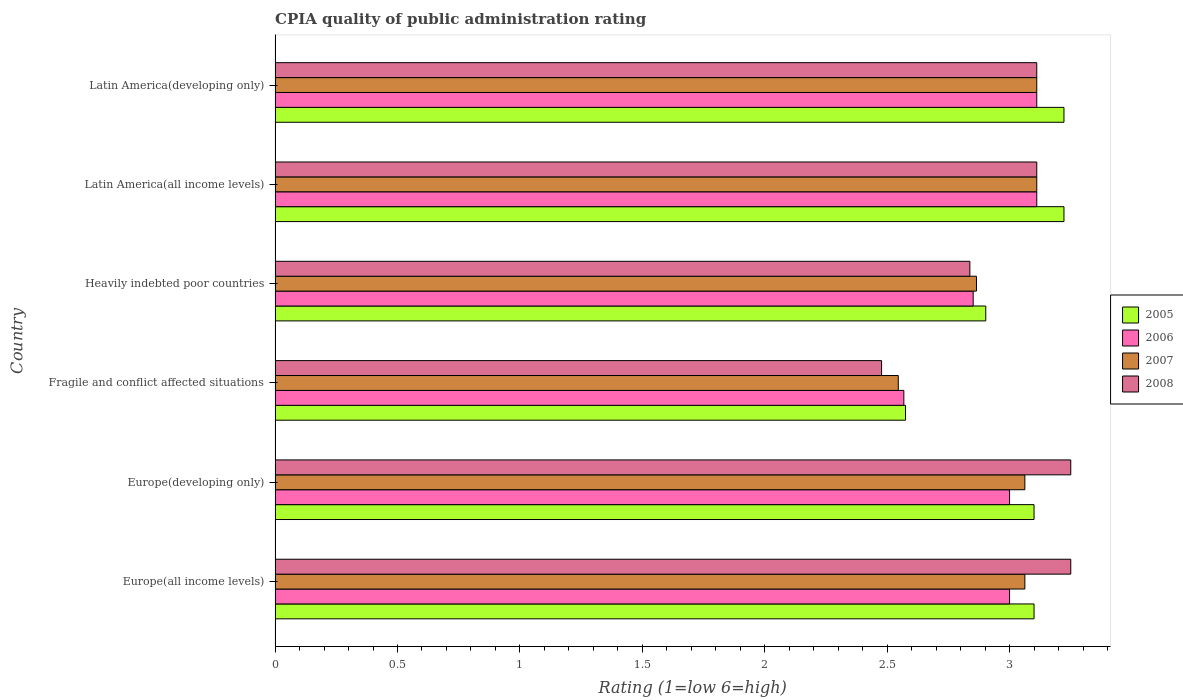How many bars are there on the 4th tick from the top?
Keep it short and to the point. 4. How many bars are there on the 6th tick from the bottom?
Offer a terse response. 4. What is the label of the 3rd group of bars from the top?
Make the answer very short. Heavily indebted poor countries. In how many cases, is the number of bars for a given country not equal to the number of legend labels?
Keep it short and to the point. 0. Across all countries, what is the maximum CPIA rating in 2007?
Keep it short and to the point. 3.11. Across all countries, what is the minimum CPIA rating in 2005?
Ensure brevity in your answer.  2.58. In which country was the CPIA rating in 2007 maximum?
Ensure brevity in your answer.  Latin America(all income levels). In which country was the CPIA rating in 2005 minimum?
Make the answer very short. Fragile and conflict affected situations. What is the total CPIA rating in 2008 in the graph?
Offer a very short reply. 18.04. What is the difference between the CPIA rating in 2006 in Europe(developing only) and that in Latin America(developing only)?
Give a very brief answer. -0.11. What is the difference between the CPIA rating in 2006 in Latin America(all income levels) and the CPIA rating in 2005 in Europe(all income levels)?
Offer a terse response. 0.01. What is the average CPIA rating in 2005 per country?
Your answer should be very brief. 3.02. What is the difference between the CPIA rating in 2005 and CPIA rating in 2007 in Latin America(all income levels)?
Make the answer very short. 0.11. What is the ratio of the CPIA rating in 2007 in Heavily indebted poor countries to that in Latin America(all income levels)?
Offer a terse response. 0.92. Is the CPIA rating in 2008 in Europe(all income levels) less than that in Latin America(all income levels)?
Provide a short and direct response. No. Is the difference between the CPIA rating in 2005 in Europe(developing only) and Latin America(developing only) greater than the difference between the CPIA rating in 2007 in Europe(developing only) and Latin America(developing only)?
Your answer should be compact. No. What is the difference between the highest and the second highest CPIA rating in 2005?
Keep it short and to the point. 0. What is the difference between the highest and the lowest CPIA rating in 2008?
Provide a short and direct response. 0.77. In how many countries, is the CPIA rating in 2005 greater than the average CPIA rating in 2005 taken over all countries?
Ensure brevity in your answer.  4. Is the sum of the CPIA rating in 2008 in Fragile and conflict affected situations and Latin America(all income levels) greater than the maximum CPIA rating in 2005 across all countries?
Keep it short and to the point. Yes. What does the 3rd bar from the top in Latin America(all income levels) represents?
Keep it short and to the point. 2006. What does the 3rd bar from the bottom in Europe(all income levels) represents?
Provide a succinct answer. 2007. Is it the case that in every country, the sum of the CPIA rating in 2007 and CPIA rating in 2008 is greater than the CPIA rating in 2005?
Provide a short and direct response. Yes. Are all the bars in the graph horizontal?
Your response must be concise. Yes. How many countries are there in the graph?
Ensure brevity in your answer.  6. Are the values on the major ticks of X-axis written in scientific E-notation?
Provide a succinct answer. No. Does the graph contain any zero values?
Provide a succinct answer. No. Does the graph contain grids?
Make the answer very short. No. Where does the legend appear in the graph?
Provide a succinct answer. Center right. How are the legend labels stacked?
Give a very brief answer. Vertical. What is the title of the graph?
Provide a succinct answer. CPIA quality of public administration rating. Does "1977" appear as one of the legend labels in the graph?
Ensure brevity in your answer.  No. What is the Rating (1=low 6=high) of 2005 in Europe(all income levels)?
Keep it short and to the point. 3.1. What is the Rating (1=low 6=high) in 2007 in Europe(all income levels)?
Keep it short and to the point. 3.06. What is the Rating (1=low 6=high) of 2008 in Europe(all income levels)?
Your answer should be very brief. 3.25. What is the Rating (1=low 6=high) of 2005 in Europe(developing only)?
Offer a very short reply. 3.1. What is the Rating (1=low 6=high) of 2007 in Europe(developing only)?
Provide a succinct answer. 3.06. What is the Rating (1=low 6=high) in 2008 in Europe(developing only)?
Offer a terse response. 3.25. What is the Rating (1=low 6=high) in 2005 in Fragile and conflict affected situations?
Provide a succinct answer. 2.58. What is the Rating (1=low 6=high) in 2006 in Fragile and conflict affected situations?
Give a very brief answer. 2.57. What is the Rating (1=low 6=high) of 2007 in Fragile and conflict affected situations?
Keep it short and to the point. 2.55. What is the Rating (1=low 6=high) in 2008 in Fragile and conflict affected situations?
Keep it short and to the point. 2.48. What is the Rating (1=low 6=high) of 2005 in Heavily indebted poor countries?
Keep it short and to the point. 2.9. What is the Rating (1=low 6=high) of 2006 in Heavily indebted poor countries?
Ensure brevity in your answer.  2.85. What is the Rating (1=low 6=high) in 2007 in Heavily indebted poor countries?
Offer a terse response. 2.86. What is the Rating (1=low 6=high) of 2008 in Heavily indebted poor countries?
Provide a short and direct response. 2.84. What is the Rating (1=low 6=high) in 2005 in Latin America(all income levels)?
Give a very brief answer. 3.22. What is the Rating (1=low 6=high) in 2006 in Latin America(all income levels)?
Give a very brief answer. 3.11. What is the Rating (1=low 6=high) of 2007 in Latin America(all income levels)?
Offer a very short reply. 3.11. What is the Rating (1=low 6=high) of 2008 in Latin America(all income levels)?
Your answer should be very brief. 3.11. What is the Rating (1=low 6=high) of 2005 in Latin America(developing only)?
Give a very brief answer. 3.22. What is the Rating (1=low 6=high) of 2006 in Latin America(developing only)?
Ensure brevity in your answer.  3.11. What is the Rating (1=low 6=high) in 2007 in Latin America(developing only)?
Make the answer very short. 3.11. What is the Rating (1=low 6=high) in 2008 in Latin America(developing only)?
Your answer should be compact. 3.11. Across all countries, what is the maximum Rating (1=low 6=high) of 2005?
Make the answer very short. 3.22. Across all countries, what is the maximum Rating (1=low 6=high) in 2006?
Offer a very short reply. 3.11. Across all countries, what is the maximum Rating (1=low 6=high) of 2007?
Your answer should be very brief. 3.11. Across all countries, what is the maximum Rating (1=low 6=high) in 2008?
Give a very brief answer. 3.25. Across all countries, what is the minimum Rating (1=low 6=high) in 2005?
Your response must be concise. 2.58. Across all countries, what is the minimum Rating (1=low 6=high) of 2006?
Provide a short and direct response. 2.57. Across all countries, what is the minimum Rating (1=low 6=high) of 2007?
Offer a very short reply. 2.55. Across all countries, what is the minimum Rating (1=low 6=high) of 2008?
Provide a succinct answer. 2.48. What is the total Rating (1=low 6=high) in 2005 in the graph?
Offer a very short reply. 18.12. What is the total Rating (1=low 6=high) of 2006 in the graph?
Your answer should be very brief. 17.64. What is the total Rating (1=low 6=high) in 2007 in the graph?
Ensure brevity in your answer.  17.76. What is the total Rating (1=low 6=high) of 2008 in the graph?
Keep it short and to the point. 18.04. What is the difference between the Rating (1=low 6=high) in 2008 in Europe(all income levels) and that in Europe(developing only)?
Offer a terse response. 0. What is the difference between the Rating (1=low 6=high) of 2005 in Europe(all income levels) and that in Fragile and conflict affected situations?
Offer a terse response. 0.53. What is the difference between the Rating (1=low 6=high) of 2006 in Europe(all income levels) and that in Fragile and conflict affected situations?
Keep it short and to the point. 0.43. What is the difference between the Rating (1=low 6=high) in 2007 in Europe(all income levels) and that in Fragile and conflict affected situations?
Your response must be concise. 0.52. What is the difference between the Rating (1=low 6=high) of 2008 in Europe(all income levels) and that in Fragile and conflict affected situations?
Offer a very short reply. 0.77. What is the difference between the Rating (1=low 6=high) of 2005 in Europe(all income levels) and that in Heavily indebted poor countries?
Your answer should be compact. 0.2. What is the difference between the Rating (1=low 6=high) of 2006 in Europe(all income levels) and that in Heavily indebted poor countries?
Offer a terse response. 0.15. What is the difference between the Rating (1=low 6=high) of 2007 in Europe(all income levels) and that in Heavily indebted poor countries?
Your answer should be very brief. 0.2. What is the difference between the Rating (1=low 6=high) of 2008 in Europe(all income levels) and that in Heavily indebted poor countries?
Provide a short and direct response. 0.41. What is the difference between the Rating (1=low 6=high) of 2005 in Europe(all income levels) and that in Latin America(all income levels)?
Make the answer very short. -0.12. What is the difference between the Rating (1=low 6=high) of 2006 in Europe(all income levels) and that in Latin America(all income levels)?
Keep it short and to the point. -0.11. What is the difference between the Rating (1=low 6=high) of 2007 in Europe(all income levels) and that in Latin America(all income levels)?
Make the answer very short. -0.05. What is the difference between the Rating (1=low 6=high) in 2008 in Europe(all income levels) and that in Latin America(all income levels)?
Make the answer very short. 0.14. What is the difference between the Rating (1=low 6=high) in 2005 in Europe(all income levels) and that in Latin America(developing only)?
Offer a very short reply. -0.12. What is the difference between the Rating (1=low 6=high) in 2006 in Europe(all income levels) and that in Latin America(developing only)?
Keep it short and to the point. -0.11. What is the difference between the Rating (1=low 6=high) in 2007 in Europe(all income levels) and that in Latin America(developing only)?
Provide a short and direct response. -0.05. What is the difference between the Rating (1=low 6=high) in 2008 in Europe(all income levels) and that in Latin America(developing only)?
Offer a terse response. 0.14. What is the difference between the Rating (1=low 6=high) of 2005 in Europe(developing only) and that in Fragile and conflict affected situations?
Provide a short and direct response. 0.53. What is the difference between the Rating (1=low 6=high) in 2006 in Europe(developing only) and that in Fragile and conflict affected situations?
Keep it short and to the point. 0.43. What is the difference between the Rating (1=low 6=high) of 2007 in Europe(developing only) and that in Fragile and conflict affected situations?
Your response must be concise. 0.52. What is the difference between the Rating (1=low 6=high) in 2008 in Europe(developing only) and that in Fragile and conflict affected situations?
Offer a terse response. 0.77. What is the difference between the Rating (1=low 6=high) in 2005 in Europe(developing only) and that in Heavily indebted poor countries?
Ensure brevity in your answer.  0.2. What is the difference between the Rating (1=low 6=high) of 2006 in Europe(developing only) and that in Heavily indebted poor countries?
Make the answer very short. 0.15. What is the difference between the Rating (1=low 6=high) in 2007 in Europe(developing only) and that in Heavily indebted poor countries?
Keep it short and to the point. 0.2. What is the difference between the Rating (1=low 6=high) in 2008 in Europe(developing only) and that in Heavily indebted poor countries?
Offer a terse response. 0.41. What is the difference between the Rating (1=low 6=high) in 2005 in Europe(developing only) and that in Latin America(all income levels)?
Keep it short and to the point. -0.12. What is the difference between the Rating (1=low 6=high) in 2006 in Europe(developing only) and that in Latin America(all income levels)?
Keep it short and to the point. -0.11. What is the difference between the Rating (1=low 6=high) of 2007 in Europe(developing only) and that in Latin America(all income levels)?
Your answer should be compact. -0.05. What is the difference between the Rating (1=low 6=high) in 2008 in Europe(developing only) and that in Latin America(all income levels)?
Your answer should be very brief. 0.14. What is the difference between the Rating (1=low 6=high) in 2005 in Europe(developing only) and that in Latin America(developing only)?
Offer a very short reply. -0.12. What is the difference between the Rating (1=low 6=high) of 2006 in Europe(developing only) and that in Latin America(developing only)?
Your response must be concise. -0.11. What is the difference between the Rating (1=low 6=high) in 2007 in Europe(developing only) and that in Latin America(developing only)?
Your answer should be compact. -0.05. What is the difference between the Rating (1=low 6=high) of 2008 in Europe(developing only) and that in Latin America(developing only)?
Provide a succinct answer. 0.14. What is the difference between the Rating (1=low 6=high) of 2005 in Fragile and conflict affected situations and that in Heavily indebted poor countries?
Provide a succinct answer. -0.33. What is the difference between the Rating (1=low 6=high) of 2006 in Fragile and conflict affected situations and that in Heavily indebted poor countries?
Your answer should be very brief. -0.28. What is the difference between the Rating (1=low 6=high) of 2007 in Fragile and conflict affected situations and that in Heavily indebted poor countries?
Offer a very short reply. -0.32. What is the difference between the Rating (1=low 6=high) of 2008 in Fragile and conflict affected situations and that in Heavily indebted poor countries?
Offer a very short reply. -0.36. What is the difference between the Rating (1=low 6=high) in 2005 in Fragile and conflict affected situations and that in Latin America(all income levels)?
Keep it short and to the point. -0.65. What is the difference between the Rating (1=low 6=high) in 2006 in Fragile and conflict affected situations and that in Latin America(all income levels)?
Your response must be concise. -0.54. What is the difference between the Rating (1=low 6=high) in 2007 in Fragile and conflict affected situations and that in Latin America(all income levels)?
Provide a succinct answer. -0.57. What is the difference between the Rating (1=low 6=high) of 2008 in Fragile and conflict affected situations and that in Latin America(all income levels)?
Your response must be concise. -0.63. What is the difference between the Rating (1=low 6=high) in 2005 in Fragile and conflict affected situations and that in Latin America(developing only)?
Make the answer very short. -0.65. What is the difference between the Rating (1=low 6=high) in 2006 in Fragile and conflict affected situations and that in Latin America(developing only)?
Your response must be concise. -0.54. What is the difference between the Rating (1=low 6=high) of 2007 in Fragile and conflict affected situations and that in Latin America(developing only)?
Your answer should be compact. -0.57. What is the difference between the Rating (1=low 6=high) of 2008 in Fragile and conflict affected situations and that in Latin America(developing only)?
Keep it short and to the point. -0.63. What is the difference between the Rating (1=low 6=high) in 2005 in Heavily indebted poor countries and that in Latin America(all income levels)?
Make the answer very short. -0.32. What is the difference between the Rating (1=low 6=high) of 2006 in Heavily indebted poor countries and that in Latin America(all income levels)?
Your answer should be very brief. -0.26. What is the difference between the Rating (1=low 6=high) in 2007 in Heavily indebted poor countries and that in Latin America(all income levels)?
Provide a short and direct response. -0.25. What is the difference between the Rating (1=low 6=high) in 2008 in Heavily indebted poor countries and that in Latin America(all income levels)?
Provide a succinct answer. -0.27. What is the difference between the Rating (1=low 6=high) of 2005 in Heavily indebted poor countries and that in Latin America(developing only)?
Your answer should be very brief. -0.32. What is the difference between the Rating (1=low 6=high) in 2006 in Heavily indebted poor countries and that in Latin America(developing only)?
Make the answer very short. -0.26. What is the difference between the Rating (1=low 6=high) of 2007 in Heavily indebted poor countries and that in Latin America(developing only)?
Keep it short and to the point. -0.25. What is the difference between the Rating (1=low 6=high) in 2008 in Heavily indebted poor countries and that in Latin America(developing only)?
Make the answer very short. -0.27. What is the difference between the Rating (1=low 6=high) of 2005 in Latin America(all income levels) and that in Latin America(developing only)?
Your answer should be compact. 0. What is the difference between the Rating (1=low 6=high) of 2007 in Latin America(all income levels) and that in Latin America(developing only)?
Provide a succinct answer. 0. What is the difference between the Rating (1=low 6=high) of 2008 in Latin America(all income levels) and that in Latin America(developing only)?
Ensure brevity in your answer.  0. What is the difference between the Rating (1=low 6=high) of 2005 in Europe(all income levels) and the Rating (1=low 6=high) of 2006 in Europe(developing only)?
Provide a succinct answer. 0.1. What is the difference between the Rating (1=low 6=high) in 2005 in Europe(all income levels) and the Rating (1=low 6=high) in 2007 in Europe(developing only)?
Offer a terse response. 0.04. What is the difference between the Rating (1=low 6=high) of 2006 in Europe(all income levels) and the Rating (1=low 6=high) of 2007 in Europe(developing only)?
Offer a terse response. -0.06. What is the difference between the Rating (1=low 6=high) of 2007 in Europe(all income levels) and the Rating (1=low 6=high) of 2008 in Europe(developing only)?
Ensure brevity in your answer.  -0.19. What is the difference between the Rating (1=low 6=high) of 2005 in Europe(all income levels) and the Rating (1=low 6=high) of 2006 in Fragile and conflict affected situations?
Give a very brief answer. 0.53. What is the difference between the Rating (1=low 6=high) of 2005 in Europe(all income levels) and the Rating (1=low 6=high) of 2007 in Fragile and conflict affected situations?
Your response must be concise. 0.55. What is the difference between the Rating (1=low 6=high) of 2005 in Europe(all income levels) and the Rating (1=low 6=high) of 2008 in Fragile and conflict affected situations?
Make the answer very short. 0.62. What is the difference between the Rating (1=low 6=high) of 2006 in Europe(all income levels) and the Rating (1=low 6=high) of 2007 in Fragile and conflict affected situations?
Your answer should be compact. 0.45. What is the difference between the Rating (1=low 6=high) of 2006 in Europe(all income levels) and the Rating (1=low 6=high) of 2008 in Fragile and conflict affected situations?
Your answer should be compact. 0.52. What is the difference between the Rating (1=low 6=high) in 2007 in Europe(all income levels) and the Rating (1=low 6=high) in 2008 in Fragile and conflict affected situations?
Offer a terse response. 0.59. What is the difference between the Rating (1=low 6=high) in 2005 in Europe(all income levels) and the Rating (1=low 6=high) in 2006 in Heavily indebted poor countries?
Give a very brief answer. 0.25. What is the difference between the Rating (1=low 6=high) in 2005 in Europe(all income levels) and the Rating (1=low 6=high) in 2007 in Heavily indebted poor countries?
Keep it short and to the point. 0.24. What is the difference between the Rating (1=low 6=high) of 2005 in Europe(all income levels) and the Rating (1=low 6=high) of 2008 in Heavily indebted poor countries?
Your answer should be very brief. 0.26. What is the difference between the Rating (1=low 6=high) of 2006 in Europe(all income levels) and the Rating (1=low 6=high) of 2007 in Heavily indebted poor countries?
Give a very brief answer. 0.14. What is the difference between the Rating (1=low 6=high) in 2006 in Europe(all income levels) and the Rating (1=low 6=high) in 2008 in Heavily indebted poor countries?
Give a very brief answer. 0.16. What is the difference between the Rating (1=low 6=high) in 2007 in Europe(all income levels) and the Rating (1=low 6=high) in 2008 in Heavily indebted poor countries?
Offer a terse response. 0.22. What is the difference between the Rating (1=low 6=high) of 2005 in Europe(all income levels) and the Rating (1=low 6=high) of 2006 in Latin America(all income levels)?
Provide a short and direct response. -0.01. What is the difference between the Rating (1=low 6=high) in 2005 in Europe(all income levels) and the Rating (1=low 6=high) in 2007 in Latin America(all income levels)?
Offer a very short reply. -0.01. What is the difference between the Rating (1=low 6=high) in 2005 in Europe(all income levels) and the Rating (1=low 6=high) in 2008 in Latin America(all income levels)?
Give a very brief answer. -0.01. What is the difference between the Rating (1=low 6=high) of 2006 in Europe(all income levels) and the Rating (1=low 6=high) of 2007 in Latin America(all income levels)?
Offer a very short reply. -0.11. What is the difference between the Rating (1=low 6=high) of 2006 in Europe(all income levels) and the Rating (1=low 6=high) of 2008 in Latin America(all income levels)?
Your answer should be compact. -0.11. What is the difference between the Rating (1=low 6=high) in 2007 in Europe(all income levels) and the Rating (1=low 6=high) in 2008 in Latin America(all income levels)?
Provide a short and direct response. -0.05. What is the difference between the Rating (1=low 6=high) of 2005 in Europe(all income levels) and the Rating (1=low 6=high) of 2006 in Latin America(developing only)?
Keep it short and to the point. -0.01. What is the difference between the Rating (1=low 6=high) in 2005 in Europe(all income levels) and the Rating (1=low 6=high) in 2007 in Latin America(developing only)?
Your response must be concise. -0.01. What is the difference between the Rating (1=low 6=high) of 2005 in Europe(all income levels) and the Rating (1=low 6=high) of 2008 in Latin America(developing only)?
Provide a short and direct response. -0.01. What is the difference between the Rating (1=low 6=high) in 2006 in Europe(all income levels) and the Rating (1=low 6=high) in 2007 in Latin America(developing only)?
Keep it short and to the point. -0.11. What is the difference between the Rating (1=low 6=high) of 2006 in Europe(all income levels) and the Rating (1=low 6=high) of 2008 in Latin America(developing only)?
Your answer should be compact. -0.11. What is the difference between the Rating (1=low 6=high) in 2007 in Europe(all income levels) and the Rating (1=low 6=high) in 2008 in Latin America(developing only)?
Your response must be concise. -0.05. What is the difference between the Rating (1=low 6=high) of 2005 in Europe(developing only) and the Rating (1=low 6=high) of 2006 in Fragile and conflict affected situations?
Make the answer very short. 0.53. What is the difference between the Rating (1=low 6=high) of 2005 in Europe(developing only) and the Rating (1=low 6=high) of 2007 in Fragile and conflict affected situations?
Keep it short and to the point. 0.55. What is the difference between the Rating (1=low 6=high) in 2005 in Europe(developing only) and the Rating (1=low 6=high) in 2008 in Fragile and conflict affected situations?
Ensure brevity in your answer.  0.62. What is the difference between the Rating (1=low 6=high) in 2006 in Europe(developing only) and the Rating (1=low 6=high) in 2007 in Fragile and conflict affected situations?
Make the answer very short. 0.45. What is the difference between the Rating (1=low 6=high) of 2006 in Europe(developing only) and the Rating (1=low 6=high) of 2008 in Fragile and conflict affected situations?
Give a very brief answer. 0.52. What is the difference between the Rating (1=low 6=high) in 2007 in Europe(developing only) and the Rating (1=low 6=high) in 2008 in Fragile and conflict affected situations?
Your answer should be compact. 0.59. What is the difference between the Rating (1=low 6=high) of 2005 in Europe(developing only) and the Rating (1=low 6=high) of 2006 in Heavily indebted poor countries?
Offer a terse response. 0.25. What is the difference between the Rating (1=low 6=high) in 2005 in Europe(developing only) and the Rating (1=low 6=high) in 2007 in Heavily indebted poor countries?
Offer a terse response. 0.24. What is the difference between the Rating (1=low 6=high) of 2005 in Europe(developing only) and the Rating (1=low 6=high) of 2008 in Heavily indebted poor countries?
Provide a succinct answer. 0.26. What is the difference between the Rating (1=low 6=high) of 2006 in Europe(developing only) and the Rating (1=low 6=high) of 2007 in Heavily indebted poor countries?
Ensure brevity in your answer.  0.14. What is the difference between the Rating (1=low 6=high) of 2006 in Europe(developing only) and the Rating (1=low 6=high) of 2008 in Heavily indebted poor countries?
Your response must be concise. 0.16. What is the difference between the Rating (1=low 6=high) of 2007 in Europe(developing only) and the Rating (1=low 6=high) of 2008 in Heavily indebted poor countries?
Keep it short and to the point. 0.22. What is the difference between the Rating (1=low 6=high) in 2005 in Europe(developing only) and the Rating (1=low 6=high) in 2006 in Latin America(all income levels)?
Offer a very short reply. -0.01. What is the difference between the Rating (1=low 6=high) in 2005 in Europe(developing only) and the Rating (1=low 6=high) in 2007 in Latin America(all income levels)?
Offer a terse response. -0.01. What is the difference between the Rating (1=low 6=high) in 2005 in Europe(developing only) and the Rating (1=low 6=high) in 2008 in Latin America(all income levels)?
Make the answer very short. -0.01. What is the difference between the Rating (1=low 6=high) of 2006 in Europe(developing only) and the Rating (1=low 6=high) of 2007 in Latin America(all income levels)?
Make the answer very short. -0.11. What is the difference between the Rating (1=low 6=high) in 2006 in Europe(developing only) and the Rating (1=low 6=high) in 2008 in Latin America(all income levels)?
Your answer should be very brief. -0.11. What is the difference between the Rating (1=low 6=high) of 2007 in Europe(developing only) and the Rating (1=low 6=high) of 2008 in Latin America(all income levels)?
Offer a terse response. -0.05. What is the difference between the Rating (1=low 6=high) in 2005 in Europe(developing only) and the Rating (1=low 6=high) in 2006 in Latin America(developing only)?
Provide a short and direct response. -0.01. What is the difference between the Rating (1=low 6=high) in 2005 in Europe(developing only) and the Rating (1=low 6=high) in 2007 in Latin America(developing only)?
Provide a short and direct response. -0.01. What is the difference between the Rating (1=low 6=high) in 2005 in Europe(developing only) and the Rating (1=low 6=high) in 2008 in Latin America(developing only)?
Ensure brevity in your answer.  -0.01. What is the difference between the Rating (1=low 6=high) of 2006 in Europe(developing only) and the Rating (1=low 6=high) of 2007 in Latin America(developing only)?
Give a very brief answer. -0.11. What is the difference between the Rating (1=low 6=high) of 2006 in Europe(developing only) and the Rating (1=low 6=high) of 2008 in Latin America(developing only)?
Your answer should be compact. -0.11. What is the difference between the Rating (1=low 6=high) of 2007 in Europe(developing only) and the Rating (1=low 6=high) of 2008 in Latin America(developing only)?
Ensure brevity in your answer.  -0.05. What is the difference between the Rating (1=low 6=high) in 2005 in Fragile and conflict affected situations and the Rating (1=low 6=high) in 2006 in Heavily indebted poor countries?
Make the answer very short. -0.28. What is the difference between the Rating (1=low 6=high) in 2005 in Fragile and conflict affected situations and the Rating (1=low 6=high) in 2007 in Heavily indebted poor countries?
Your answer should be very brief. -0.29. What is the difference between the Rating (1=low 6=high) in 2005 in Fragile and conflict affected situations and the Rating (1=low 6=high) in 2008 in Heavily indebted poor countries?
Give a very brief answer. -0.26. What is the difference between the Rating (1=low 6=high) of 2006 in Fragile and conflict affected situations and the Rating (1=low 6=high) of 2007 in Heavily indebted poor countries?
Give a very brief answer. -0.3. What is the difference between the Rating (1=low 6=high) of 2006 in Fragile and conflict affected situations and the Rating (1=low 6=high) of 2008 in Heavily indebted poor countries?
Your answer should be compact. -0.27. What is the difference between the Rating (1=low 6=high) in 2007 in Fragile and conflict affected situations and the Rating (1=low 6=high) in 2008 in Heavily indebted poor countries?
Offer a very short reply. -0.29. What is the difference between the Rating (1=low 6=high) of 2005 in Fragile and conflict affected situations and the Rating (1=low 6=high) of 2006 in Latin America(all income levels)?
Provide a succinct answer. -0.54. What is the difference between the Rating (1=low 6=high) in 2005 in Fragile and conflict affected situations and the Rating (1=low 6=high) in 2007 in Latin America(all income levels)?
Provide a succinct answer. -0.54. What is the difference between the Rating (1=low 6=high) in 2005 in Fragile and conflict affected situations and the Rating (1=low 6=high) in 2008 in Latin America(all income levels)?
Provide a succinct answer. -0.54. What is the difference between the Rating (1=low 6=high) of 2006 in Fragile and conflict affected situations and the Rating (1=low 6=high) of 2007 in Latin America(all income levels)?
Keep it short and to the point. -0.54. What is the difference between the Rating (1=low 6=high) of 2006 in Fragile and conflict affected situations and the Rating (1=low 6=high) of 2008 in Latin America(all income levels)?
Make the answer very short. -0.54. What is the difference between the Rating (1=low 6=high) of 2007 in Fragile and conflict affected situations and the Rating (1=low 6=high) of 2008 in Latin America(all income levels)?
Make the answer very short. -0.57. What is the difference between the Rating (1=low 6=high) of 2005 in Fragile and conflict affected situations and the Rating (1=low 6=high) of 2006 in Latin America(developing only)?
Offer a terse response. -0.54. What is the difference between the Rating (1=low 6=high) in 2005 in Fragile and conflict affected situations and the Rating (1=low 6=high) in 2007 in Latin America(developing only)?
Provide a succinct answer. -0.54. What is the difference between the Rating (1=low 6=high) of 2005 in Fragile and conflict affected situations and the Rating (1=low 6=high) of 2008 in Latin America(developing only)?
Give a very brief answer. -0.54. What is the difference between the Rating (1=low 6=high) in 2006 in Fragile and conflict affected situations and the Rating (1=low 6=high) in 2007 in Latin America(developing only)?
Offer a very short reply. -0.54. What is the difference between the Rating (1=low 6=high) of 2006 in Fragile and conflict affected situations and the Rating (1=low 6=high) of 2008 in Latin America(developing only)?
Offer a terse response. -0.54. What is the difference between the Rating (1=low 6=high) of 2007 in Fragile and conflict affected situations and the Rating (1=low 6=high) of 2008 in Latin America(developing only)?
Your answer should be compact. -0.57. What is the difference between the Rating (1=low 6=high) of 2005 in Heavily indebted poor countries and the Rating (1=low 6=high) of 2006 in Latin America(all income levels)?
Keep it short and to the point. -0.21. What is the difference between the Rating (1=low 6=high) of 2005 in Heavily indebted poor countries and the Rating (1=low 6=high) of 2007 in Latin America(all income levels)?
Your response must be concise. -0.21. What is the difference between the Rating (1=low 6=high) of 2005 in Heavily indebted poor countries and the Rating (1=low 6=high) of 2008 in Latin America(all income levels)?
Your answer should be very brief. -0.21. What is the difference between the Rating (1=low 6=high) in 2006 in Heavily indebted poor countries and the Rating (1=low 6=high) in 2007 in Latin America(all income levels)?
Make the answer very short. -0.26. What is the difference between the Rating (1=low 6=high) in 2006 in Heavily indebted poor countries and the Rating (1=low 6=high) in 2008 in Latin America(all income levels)?
Provide a succinct answer. -0.26. What is the difference between the Rating (1=low 6=high) of 2007 in Heavily indebted poor countries and the Rating (1=low 6=high) of 2008 in Latin America(all income levels)?
Keep it short and to the point. -0.25. What is the difference between the Rating (1=low 6=high) of 2005 in Heavily indebted poor countries and the Rating (1=low 6=high) of 2006 in Latin America(developing only)?
Your answer should be very brief. -0.21. What is the difference between the Rating (1=low 6=high) of 2005 in Heavily indebted poor countries and the Rating (1=low 6=high) of 2007 in Latin America(developing only)?
Offer a very short reply. -0.21. What is the difference between the Rating (1=low 6=high) of 2005 in Heavily indebted poor countries and the Rating (1=low 6=high) of 2008 in Latin America(developing only)?
Your answer should be very brief. -0.21. What is the difference between the Rating (1=low 6=high) in 2006 in Heavily indebted poor countries and the Rating (1=low 6=high) in 2007 in Latin America(developing only)?
Your answer should be very brief. -0.26. What is the difference between the Rating (1=low 6=high) of 2006 in Heavily indebted poor countries and the Rating (1=low 6=high) of 2008 in Latin America(developing only)?
Offer a very short reply. -0.26. What is the difference between the Rating (1=low 6=high) of 2007 in Heavily indebted poor countries and the Rating (1=low 6=high) of 2008 in Latin America(developing only)?
Provide a short and direct response. -0.25. What is the difference between the Rating (1=low 6=high) of 2005 in Latin America(all income levels) and the Rating (1=low 6=high) of 2006 in Latin America(developing only)?
Offer a terse response. 0.11. What is the difference between the Rating (1=low 6=high) of 2005 in Latin America(all income levels) and the Rating (1=low 6=high) of 2008 in Latin America(developing only)?
Give a very brief answer. 0.11. What is the difference between the Rating (1=low 6=high) in 2006 in Latin America(all income levels) and the Rating (1=low 6=high) in 2007 in Latin America(developing only)?
Give a very brief answer. 0. What is the difference between the Rating (1=low 6=high) in 2006 in Latin America(all income levels) and the Rating (1=low 6=high) in 2008 in Latin America(developing only)?
Your response must be concise. 0. What is the difference between the Rating (1=low 6=high) in 2007 in Latin America(all income levels) and the Rating (1=low 6=high) in 2008 in Latin America(developing only)?
Your response must be concise. 0. What is the average Rating (1=low 6=high) of 2005 per country?
Your response must be concise. 3.02. What is the average Rating (1=low 6=high) in 2006 per country?
Provide a succinct answer. 2.94. What is the average Rating (1=low 6=high) of 2007 per country?
Provide a succinct answer. 2.96. What is the average Rating (1=low 6=high) of 2008 per country?
Ensure brevity in your answer.  3.01. What is the difference between the Rating (1=low 6=high) of 2005 and Rating (1=low 6=high) of 2007 in Europe(all income levels)?
Your answer should be very brief. 0.04. What is the difference between the Rating (1=low 6=high) of 2006 and Rating (1=low 6=high) of 2007 in Europe(all income levels)?
Your response must be concise. -0.06. What is the difference between the Rating (1=low 6=high) of 2006 and Rating (1=low 6=high) of 2008 in Europe(all income levels)?
Keep it short and to the point. -0.25. What is the difference between the Rating (1=low 6=high) of 2007 and Rating (1=low 6=high) of 2008 in Europe(all income levels)?
Make the answer very short. -0.19. What is the difference between the Rating (1=low 6=high) of 2005 and Rating (1=low 6=high) of 2007 in Europe(developing only)?
Your response must be concise. 0.04. What is the difference between the Rating (1=low 6=high) in 2005 and Rating (1=low 6=high) in 2008 in Europe(developing only)?
Provide a succinct answer. -0.15. What is the difference between the Rating (1=low 6=high) of 2006 and Rating (1=low 6=high) of 2007 in Europe(developing only)?
Keep it short and to the point. -0.06. What is the difference between the Rating (1=low 6=high) in 2007 and Rating (1=low 6=high) in 2008 in Europe(developing only)?
Offer a very short reply. -0.19. What is the difference between the Rating (1=low 6=high) of 2005 and Rating (1=low 6=high) of 2006 in Fragile and conflict affected situations?
Give a very brief answer. 0.01. What is the difference between the Rating (1=low 6=high) in 2005 and Rating (1=low 6=high) in 2007 in Fragile and conflict affected situations?
Make the answer very short. 0.03. What is the difference between the Rating (1=low 6=high) in 2005 and Rating (1=low 6=high) in 2008 in Fragile and conflict affected situations?
Provide a short and direct response. 0.1. What is the difference between the Rating (1=low 6=high) of 2006 and Rating (1=low 6=high) of 2007 in Fragile and conflict affected situations?
Provide a succinct answer. 0.02. What is the difference between the Rating (1=low 6=high) of 2006 and Rating (1=low 6=high) of 2008 in Fragile and conflict affected situations?
Give a very brief answer. 0.09. What is the difference between the Rating (1=low 6=high) in 2007 and Rating (1=low 6=high) in 2008 in Fragile and conflict affected situations?
Provide a succinct answer. 0.07. What is the difference between the Rating (1=low 6=high) in 2005 and Rating (1=low 6=high) in 2006 in Heavily indebted poor countries?
Provide a short and direct response. 0.05. What is the difference between the Rating (1=low 6=high) in 2005 and Rating (1=low 6=high) in 2007 in Heavily indebted poor countries?
Offer a very short reply. 0.04. What is the difference between the Rating (1=low 6=high) of 2005 and Rating (1=low 6=high) of 2008 in Heavily indebted poor countries?
Your answer should be compact. 0.06. What is the difference between the Rating (1=low 6=high) in 2006 and Rating (1=low 6=high) in 2007 in Heavily indebted poor countries?
Ensure brevity in your answer.  -0.01. What is the difference between the Rating (1=low 6=high) of 2006 and Rating (1=low 6=high) of 2008 in Heavily indebted poor countries?
Keep it short and to the point. 0.01. What is the difference between the Rating (1=low 6=high) of 2007 and Rating (1=low 6=high) of 2008 in Heavily indebted poor countries?
Make the answer very short. 0.03. What is the difference between the Rating (1=low 6=high) in 2005 and Rating (1=low 6=high) in 2007 in Latin America(all income levels)?
Your answer should be very brief. 0.11. What is the difference between the Rating (1=low 6=high) of 2005 and Rating (1=low 6=high) of 2008 in Latin America(all income levels)?
Your answer should be very brief. 0.11. What is the difference between the Rating (1=low 6=high) in 2006 and Rating (1=low 6=high) in 2008 in Latin America(all income levels)?
Keep it short and to the point. 0. What is the difference between the Rating (1=low 6=high) of 2005 and Rating (1=low 6=high) of 2007 in Latin America(developing only)?
Your response must be concise. 0.11. What is the difference between the Rating (1=low 6=high) in 2005 and Rating (1=low 6=high) in 2008 in Latin America(developing only)?
Ensure brevity in your answer.  0.11. What is the ratio of the Rating (1=low 6=high) in 2006 in Europe(all income levels) to that in Europe(developing only)?
Provide a short and direct response. 1. What is the ratio of the Rating (1=low 6=high) in 2005 in Europe(all income levels) to that in Fragile and conflict affected situations?
Your answer should be very brief. 1.2. What is the ratio of the Rating (1=low 6=high) of 2006 in Europe(all income levels) to that in Fragile and conflict affected situations?
Give a very brief answer. 1.17. What is the ratio of the Rating (1=low 6=high) of 2007 in Europe(all income levels) to that in Fragile and conflict affected situations?
Your answer should be very brief. 1.2. What is the ratio of the Rating (1=low 6=high) of 2008 in Europe(all income levels) to that in Fragile and conflict affected situations?
Provide a short and direct response. 1.31. What is the ratio of the Rating (1=low 6=high) in 2005 in Europe(all income levels) to that in Heavily indebted poor countries?
Your answer should be very brief. 1.07. What is the ratio of the Rating (1=low 6=high) of 2006 in Europe(all income levels) to that in Heavily indebted poor countries?
Provide a succinct answer. 1.05. What is the ratio of the Rating (1=low 6=high) in 2007 in Europe(all income levels) to that in Heavily indebted poor countries?
Your answer should be very brief. 1.07. What is the ratio of the Rating (1=low 6=high) of 2008 in Europe(all income levels) to that in Heavily indebted poor countries?
Ensure brevity in your answer.  1.15. What is the ratio of the Rating (1=low 6=high) in 2005 in Europe(all income levels) to that in Latin America(all income levels)?
Offer a very short reply. 0.96. What is the ratio of the Rating (1=low 6=high) of 2007 in Europe(all income levels) to that in Latin America(all income levels)?
Give a very brief answer. 0.98. What is the ratio of the Rating (1=low 6=high) in 2008 in Europe(all income levels) to that in Latin America(all income levels)?
Keep it short and to the point. 1.04. What is the ratio of the Rating (1=low 6=high) in 2005 in Europe(all income levels) to that in Latin America(developing only)?
Keep it short and to the point. 0.96. What is the ratio of the Rating (1=low 6=high) of 2006 in Europe(all income levels) to that in Latin America(developing only)?
Offer a terse response. 0.96. What is the ratio of the Rating (1=low 6=high) in 2007 in Europe(all income levels) to that in Latin America(developing only)?
Offer a terse response. 0.98. What is the ratio of the Rating (1=low 6=high) of 2008 in Europe(all income levels) to that in Latin America(developing only)?
Offer a terse response. 1.04. What is the ratio of the Rating (1=low 6=high) of 2005 in Europe(developing only) to that in Fragile and conflict affected situations?
Your answer should be very brief. 1.2. What is the ratio of the Rating (1=low 6=high) in 2006 in Europe(developing only) to that in Fragile and conflict affected situations?
Offer a very short reply. 1.17. What is the ratio of the Rating (1=low 6=high) of 2007 in Europe(developing only) to that in Fragile and conflict affected situations?
Your answer should be compact. 1.2. What is the ratio of the Rating (1=low 6=high) of 2008 in Europe(developing only) to that in Fragile and conflict affected situations?
Ensure brevity in your answer.  1.31. What is the ratio of the Rating (1=low 6=high) in 2005 in Europe(developing only) to that in Heavily indebted poor countries?
Ensure brevity in your answer.  1.07. What is the ratio of the Rating (1=low 6=high) of 2006 in Europe(developing only) to that in Heavily indebted poor countries?
Provide a short and direct response. 1.05. What is the ratio of the Rating (1=low 6=high) of 2007 in Europe(developing only) to that in Heavily indebted poor countries?
Provide a short and direct response. 1.07. What is the ratio of the Rating (1=low 6=high) of 2008 in Europe(developing only) to that in Heavily indebted poor countries?
Your answer should be compact. 1.15. What is the ratio of the Rating (1=low 6=high) of 2005 in Europe(developing only) to that in Latin America(all income levels)?
Your answer should be very brief. 0.96. What is the ratio of the Rating (1=low 6=high) of 2007 in Europe(developing only) to that in Latin America(all income levels)?
Keep it short and to the point. 0.98. What is the ratio of the Rating (1=low 6=high) of 2008 in Europe(developing only) to that in Latin America(all income levels)?
Provide a short and direct response. 1.04. What is the ratio of the Rating (1=low 6=high) of 2005 in Europe(developing only) to that in Latin America(developing only)?
Give a very brief answer. 0.96. What is the ratio of the Rating (1=low 6=high) of 2006 in Europe(developing only) to that in Latin America(developing only)?
Offer a very short reply. 0.96. What is the ratio of the Rating (1=low 6=high) in 2007 in Europe(developing only) to that in Latin America(developing only)?
Your response must be concise. 0.98. What is the ratio of the Rating (1=low 6=high) of 2008 in Europe(developing only) to that in Latin America(developing only)?
Your answer should be compact. 1.04. What is the ratio of the Rating (1=low 6=high) in 2005 in Fragile and conflict affected situations to that in Heavily indebted poor countries?
Make the answer very short. 0.89. What is the ratio of the Rating (1=low 6=high) in 2006 in Fragile and conflict affected situations to that in Heavily indebted poor countries?
Keep it short and to the point. 0.9. What is the ratio of the Rating (1=low 6=high) in 2007 in Fragile and conflict affected situations to that in Heavily indebted poor countries?
Ensure brevity in your answer.  0.89. What is the ratio of the Rating (1=low 6=high) in 2008 in Fragile and conflict affected situations to that in Heavily indebted poor countries?
Provide a succinct answer. 0.87. What is the ratio of the Rating (1=low 6=high) in 2005 in Fragile and conflict affected situations to that in Latin America(all income levels)?
Give a very brief answer. 0.8. What is the ratio of the Rating (1=low 6=high) in 2006 in Fragile and conflict affected situations to that in Latin America(all income levels)?
Make the answer very short. 0.83. What is the ratio of the Rating (1=low 6=high) of 2007 in Fragile and conflict affected situations to that in Latin America(all income levels)?
Offer a very short reply. 0.82. What is the ratio of the Rating (1=low 6=high) in 2008 in Fragile and conflict affected situations to that in Latin America(all income levels)?
Keep it short and to the point. 0.8. What is the ratio of the Rating (1=low 6=high) in 2005 in Fragile and conflict affected situations to that in Latin America(developing only)?
Your answer should be compact. 0.8. What is the ratio of the Rating (1=low 6=high) of 2006 in Fragile and conflict affected situations to that in Latin America(developing only)?
Keep it short and to the point. 0.83. What is the ratio of the Rating (1=low 6=high) in 2007 in Fragile and conflict affected situations to that in Latin America(developing only)?
Your response must be concise. 0.82. What is the ratio of the Rating (1=low 6=high) in 2008 in Fragile and conflict affected situations to that in Latin America(developing only)?
Keep it short and to the point. 0.8. What is the ratio of the Rating (1=low 6=high) of 2005 in Heavily indebted poor countries to that in Latin America(all income levels)?
Ensure brevity in your answer.  0.9. What is the ratio of the Rating (1=low 6=high) in 2006 in Heavily indebted poor countries to that in Latin America(all income levels)?
Ensure brevity in your answer.  0.92. What is the ratio of the Rating (1=low 6=high) in 2007 in Heavily indebted poor countries to that in Latin America(all income levels)?
Provide a succinct answer. 0.92. What is the ratio of the Rating (1=low 6=high) in 2008 in Heavily indebted poor countries to that in Latin America(all income levels)?
Give a very brief answer. 0.91. What is the ratio of the Rating (1=low 6=high) of 2005 in Heavily indebted poor countries to that in Latin America(developing only)?
Offer a very short reply. 0.9. What is the ratio of the Rating (1=low 6=high) of 2006 in Heavily indebted poor countries to that in Latin America(developing only)?
Keep it short and to the point. 0.92. What is the ratio of the Rating (1=low 6=high) of 2007 in Heavily indebted poor countries to that in Latin America(developing only)?
Offer a very short reply. 0.92. What is the ratio of the Rating (1=low 6=high) of 2008 in Heavily indebted poor countries to that in Latin America(developing only)?
Offer a terse response. 0.91. What is the ratio of the Rating (1=low 6=high) of 2005 in Latin America(all income levels) to that in Latin America(developing only)?
Make the answer very short. 1. What is the difference between the highest and the second highest Rating (1=low 6=high) in 2005?
Make the answer very short. 0. What is the difference between the highest and the second highest Rating (1=low 6=high) of 2006?
Give a very brief answer. 0. What is the difference between the highest and the second highest Rating (1=low 6=high) in 2007?
Offer a terse response. 0. What is the difference between the highest and the second highest Rating (1=low 6=high) of 2008?
Your answer should be compact. 0. What is the difference between the highest and the lowest Rating (1=low 6=high) in 2005?
Your answer should be very brief. 0.65. What is the difference between the highest and the lowest Rating (1=low 6=high) in 2006?
Keep it short and to the point. 0.54. What is the difference between the highest and the lowest Rating (1=low 6=high) of 2007?
Keep it short and to the point. 0.57. What is the difference between the highest and the lowest Rating (1=low 6=high) of 2008?
Make the answer very short. 0.77. 